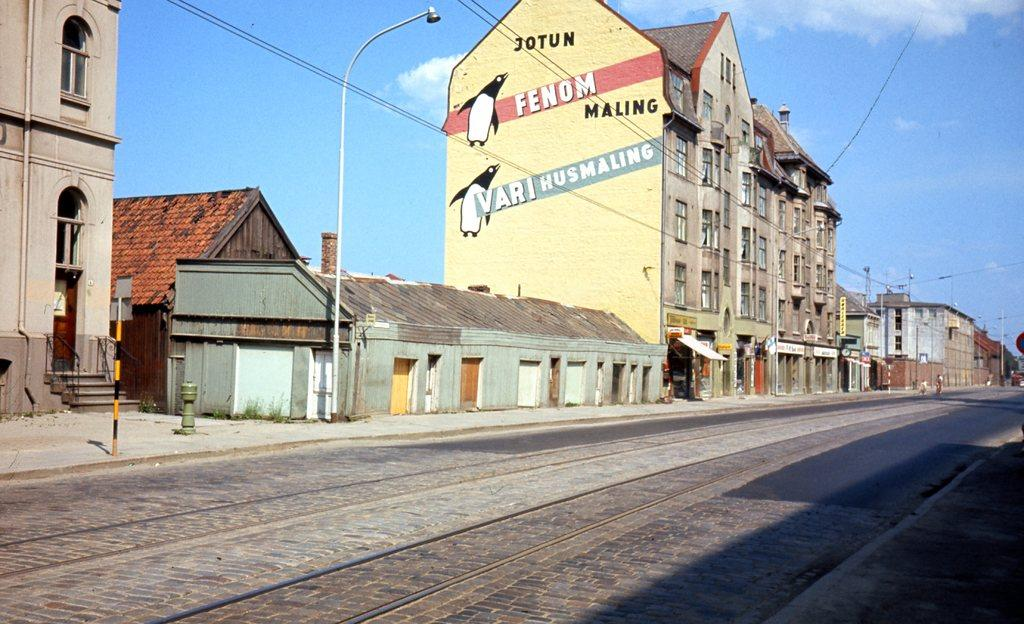What type of transportation infrastructure is visible in the image? There are railway tracks in the image. What else can be seen alongside the railway tracks? There are poles and street lights in the image. What type of structures are present in the background of the image? There are houses and buildings in the image, and they have windows. What is visible in the sky in the image? The sky is visible in the image, and there are clouds present. What type of dress is being worn by the sponge in the image? There is no sponge or dress present in the image. 